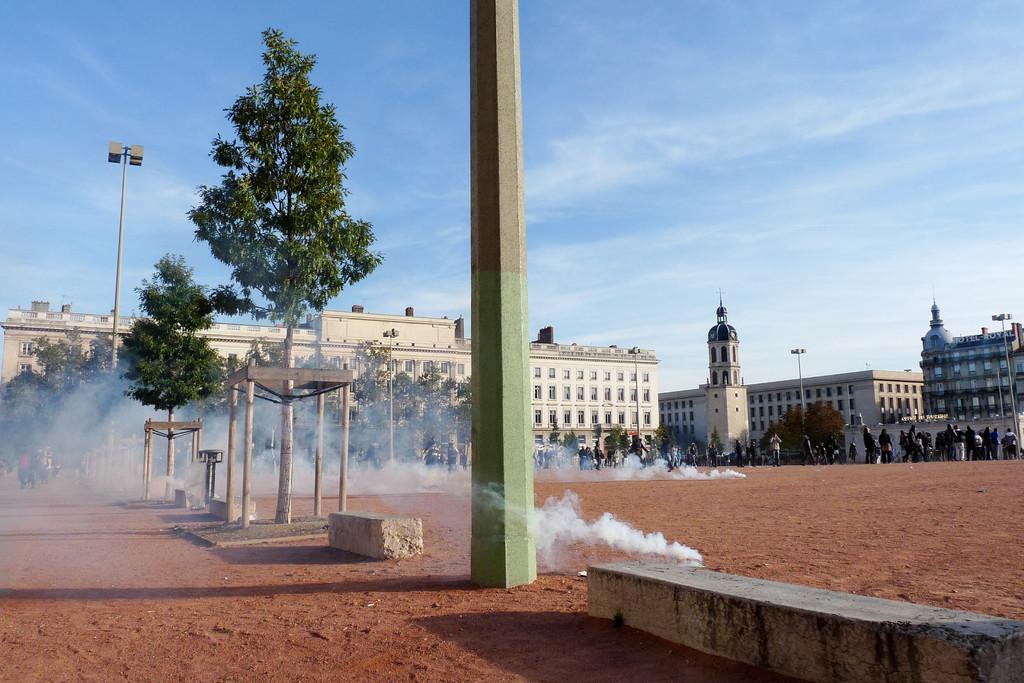Could you give a brief overview of what you see in this image? In the image there is a pillar in the middle of the sandy land, in the back there are many buildings with many people standing in front of it protesting with smoke bombs and above its sky with clouds. 